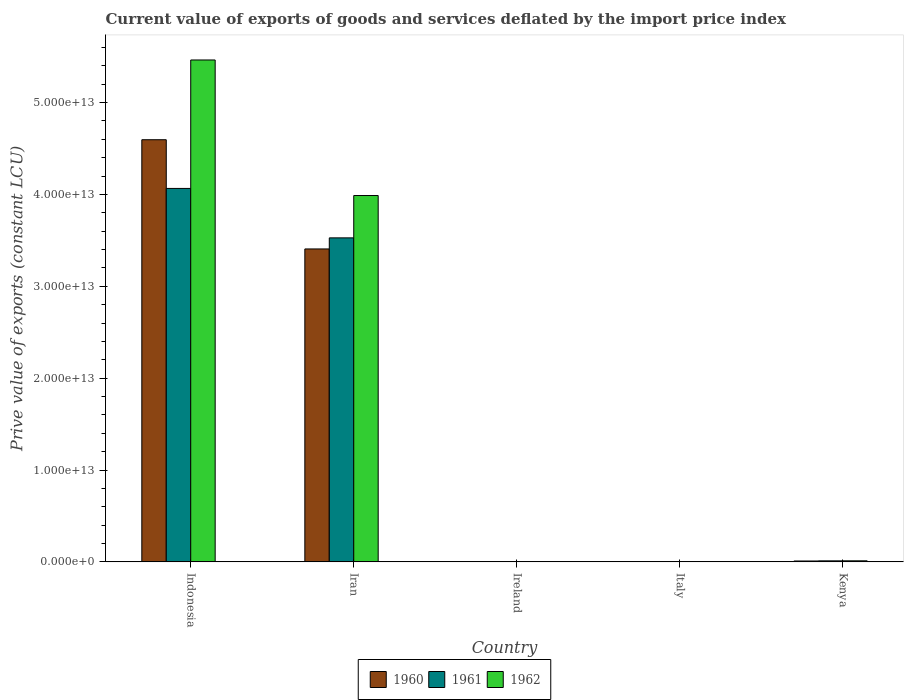How many different coloured bars are there?
Make the answer very short. 3. How many groups of bars are there?
Ensure brevity in your answer.  5. Are the number of bars per tick equal to the number of legend labels?
Make the answer very short. Yes. Are the number of bars on each tick of the X-axis equal?
Make the answer very short. Yes. How many bars are there on the 3rd tick from the left?
Offer a very short reply. 3. How many bars are there on the 4th tick from the right?
Your answer should be very brief. 3. What is the label of the 5th group of bars from the left?
Provide a succinct answer. Kenya. In how many cases, is the number of bars for a given country not equal to the number of legend labels?
Offer a terse response. 0. What is the prive value of exports in 1962 in Ireland?
Offer a terse response. 3.23e+09. Across all countries, what is the maximum prive value of exports in 1960?
Make the answer very short. 4.60e+13. Across all countries, what is the minimum prive value of exports in 1961?
Your response must be concise. 3.22e+09. In which country was the prive value of exports in 1961 minimum?
Your response must be concise. Ireland. What is the total prive value of exports in 1962 in the graph?
Offer a terse response. 9.47e+13. What is the difference between the prive value of exports in 1960 in Indonesia and that in Ireland?
Offer a terse response. 4.59e+13. What is the difference between the prive value of exports in 1960 in Kenya and the prive value of exports in 1961 in Iran?
Give a very brief answer. -3.52e+13. What is the average prive value of exports in 1961 per country?
Make the answer very short. 1.52e+13. What is the difference between the prive value of exports of/in 1961 and prive value of exports of/in 1962 in Kenya?
Make the answer very short. -3.47e+09. In how many countries, is the prive value of exports in 1960 greater than 48000000000000 LCU?
Your answer should be compact. 0. What is the ratio of the prive value of exports in 1960 in Italy to that in Kenya?
Make the answer very short. 0.3. Is the prive value of exports in 1961 in Indonesia less than that in Iran?
Give a very brief answer. No. Is the difference between the prive value of exports in 1961 in Ireland and Italy greater than the difference between the prive value of exports in 1962 in Ireland and Italy?
Your answer should be very brief. Yes. What is the difference between the highest and the second highest prive value of exports in 1962?
Make the answer very short. 3.98e+13. What is the difference between the highest and the lowest prive value of exports in 1961?
Your answer should be compact. 4.06e+13. In how many countries, is the prive value of exports in 1961 greater than the average prive value of exports in 1961 taken over all countries?
Your response must be concise. 2. Is the sum of the prive value of exports in 1960 in Iran and Italy greater than the maximum prive value of exports in 1962 across all countries?
Your answer should be very brief. No. How many bars are there?
Offer a terse response. 15. Are all the bars in the graph horizontal?
Keep it short and to the point. No. What is the difference between two consecutive major ticks on the Y-axis?
Offer a terse response. 1.00e+13. Are the values on the major ticks of Y-axis written in scientific E-notation?
Your answer should be compact. Yes. Where does the legend appear in the graph?
Provide a short and direct response. Bottom center. What is the title of the graph?
Ensure brevity in your answer.  Current value of exports of goods and services deflated by the import price index. Does "2001" appear as one of the legend labels in the graph?
Give a very brief answer. No. What is the label or title of the X-axis?
Make the answer very short. Country. What is the label or title of the Y-axis?
Make the answer very short. Prive value of exports (constant LCU). What is the Prive value of exports (constant LCU) of 1960 in Indonesia?
Make the answer very short. 4.60e+13. What is the Prive value of exports (constant LCU) of 1961 in Indonesia?
Your answer should be very brief. 4.07e+13. What is the Prive value of exports (constant LCU) in 1962 in Indonesia?
Provide a short and direct response. 5.46e+13. What is the Prive value of exports (constant LCU) in 1960 in Iran?
Provide a short and direct response. 3.41e+13. What is the Prive value of exports (constant LCU) of 1961 in Iran?
Your answer should be very brief. 3.53e+13. What is the Prive value of exports (constant LCU) in 1962 in Iran?
Make the answer very short. 3.99e+13. What is the Prive value of exports (constant LCU) in 1960 in Ireland?
Ensure brevity in your answer.  2.78e+09. What is the Prive value of exports (constant LCU) of 1961 in Ireland?
Give a very brief answer. 3.22e+09. What is the Prive value of exports (constant LCU) in 1962 in Ireland?
Provide a short and direct response. 3.23e+09. What is the Prive value of exports (constant LCU) in 1960 in Italy?
Your answer should be compact. 2.88e+1. What is the Prive value of exports (constant LCU) of 1961 in Italy?
Provide a short and direct response. 3.35e+1. What is the Prive value of exports (constant LCU) of 1962 in Italy?
Provide a succinct answer. 3.72e+1. What is the Prive value of exports (constant LCU) in 1960 in Kenya?
Your response must be concise. 9.59e+1. What is the Prive value of exports (constant LCU) of 1961 in Kenya?
Provide a short and direct response. 1.11e+11. What is the Prive value of exports (constant LCU) of 1962 in Kenya?
Keep it short and to the point. 1.15e+11. Across all countries, what is the maximum Prive value of exports (constant LCU) of 1960?
Provide a short and direct response. 4.60e+13. Across all countries, what is the maximum Prive value of exports (constant LCU) of 1961?
Ensure brevity in your answer.  4.07e+13. Across all countries, what is the maximum Prive value of exports (constant LCU) in 1962?
Keep it short and to the point. 5.46e+13. Across all countries, what is the minimum Prive value of exports (constant LCU) of 1960?
Your answer should be very brief. 2.78e+09. Across all countries, what is the minimum Prive value of exports (constant LCU) in 1961?
Provide a succinct answer. 3.22e+09. Across all countries, what is the minimum Prive value of exports (constant LCU) of 1962?
Your answer should be compact. 3.23e+09. What is the total Prive value of exports (constant LCU) of 1960 in the graph?
Ensure brevity in your answer.  8.01e+13. What is the total Prive value of exports (constant LCU) of 1961 in the graph?
Provide a short and direct response. 7.61e+13. What is the total Prive value of exports (constant LCU) in 1962 in the graph?
Provide a short and direct response. 9.47e+13. What is the difference between the Prive value of exports (constant LCU) in 1960 in Indonesia and that in Iran?
Ensure brevity in your answer.  1.19e+13. What is the difference between the Prive value of exports (constant LCU) in 1961 in Indonesia and that in Iran?
Your answer should be very brief. 5.38e+12. What is the difference between the Prive value of exports (constant LCU) of 1962 in Indonesia and that in Iran?
Make the answer very short. 1.48e+13. What is the difference between the Prive value of exports (constant LCU) of 1960 in Indonesia and that in Ireland?
Your response must be concise. 4.59e+13. What is the difference between the Prive value of exports (constant LCU) in 1961 in Indonesia and that in Ireland?
Offer a terse response. 4.06e+13. What is the difference between the Prive value of exports (constant LCU) in 1962 in Indonesia and that in Ireland?
Your answer should be very brief. 5.46e+13. What is the difference between the Prive value of exports (constant LCU) of 1960 in Indonesia and that in Italy?
Offer a very short reply. 4.59e+13. What is the difference between the Prive value of exports (constant LCU) in 1961 in Indonesia and that in Italy?
Provide a short and direct response. 4.06e+13. What is the difference between the Prive value of exports (constant LCU) in 1962 in Indonesia and that in Italy?
Provide a short and direct response. 5.46e+13. What is the difference between the Prive value of exports (constant LCU) of 1960 in Indonesia and that in Kenya?
Offer a very short reply. 4.59e+13. What is the difference between the Prive value of exports (constant LCU) of 1961 in Indonesia and that in Kenya?
Ensure brevity in your answer.  4.05e+13. What is the difference between the Prive value of exports (constant LCU) of 1962 in Indonesia and that in Kenya?
Make the answer very short. 5.45e+13. What is the difference between the Prive value of exports (constant LCU) in 1960 in Iran and that in Ireland?
Give a very brief answer. 3.41e+13. What is the difference between the Prive value of exports (constant LCU) of 1961 in Iran and that in Ireland?
Provide a short and direct response. 3.53e+13. What is the difference between the Prive value of exports (constant LCU) of 1962 in Iran and that in Ireland?
Ensure brevity in your answer.  3.99e+13. What is the difference between the Prive value of exports (constant LCU) in 1960 in Iran and that in Italy?
Make the answer very short. 3.40e+13. What is the difference between the Prive value of exports (constant LCU) of 1961 in Iran and that in Italy?
Provide a succinct answer. 3.52e+13. What is the difference between the Prive value of exports (constant LCU) of 1962 in Iran and that in Italy?
Provide a short and direct response. 3.98e+13. What is the difference between the Prive value of exports (constant LCU) in 1960 in Iran and that in Kenya?
Ensure brevity in your answer.  3.40e+13. What is the difference between the Prive value of exports (constant LCU) in 1961 in Iran and that in Kenya?
Your answer should be compact. 3.52e+13. What is the difference between the Prive value of exports (constant LCU) of 1962 in Iran and that in Kenya?
Provide a short and direct response. 3.98e+13. What is the difference between the Prive value of exports (constant LCU) of 1960 in Ireland and that in Italy?
Keep it short and to the point. -2.60e+1. What is the difference between the Prive value of exports (constant LCU) of 1961 in Ireland and that in Italy?
Your answer should be compact. -3.03e+1. What is the difference between the Prive value of exports (constant LCU) in 1962 in Ireland and that in Italy?
Give a very brief answer. -3.40e+1. What is the difference between the Prive value of exports (constant LCU) of 1960 in Ireland and that in Kenya?
Your answer should be compact. -9.31e+1. What is the difference between the Prive value of exports (constant LCU) of 1961 in Ireland and that in Kenya?
Provide a succinct answer. -1.08e+11. What is the difference between the Prive value of exports (constant LCU) of 1962 in Ireland and that in Kenya?
Make the answer very short. -1.11e+11. What is the difference between the Prive value of exports (constant LCU) in 1960 in Italy and that in Kenya?
Your answer should be compact. -6.71e+1. What is the difference between the Prive value of exports (constant LCU) of 1961 in Italy and that in Kenya?
Offer a terse response. -7.77e+1. What is the difference between the Prive value of exports (constant LCU) of 1962 in Italy and that in Kenya?
Your answer should be very brief. -7.75e+1. What is the difference between the Prive value of exports (constant LCU) of 1960 in Indonesia and the Prive value of exports (constant LCU) of 1961 in Iran?
Your answer should be very brief. 1.07e+13. What is the difference between the Prive value of exports (constant LCU) of 1960 in Indonesia and the Prive value of exports (constant LCU) of 1962 in Iran?
Your response must be concise. 6.07e+12. What is the difference between the Prive value of exports (constant LCU) of 1961 in Indonesia and the Prive value of exports (constant LCU) of 1962 in Iran?
Provide a short and direct response. 7.73e+11. What is the difference between the Prive value of exports (constant LCU) in 1960 in Indonesia and the Prive value of exports (constant LCU) in 1961 in Ireland?
Make the answer very short. 4.59e+13. What is the difference between the Prive value of exports (constant LCU) of 1960 in Indonesia and the Prive value of exports (constant LCU) of 1962 in Ireland?
Offer a very short reply. 4.59e+13. What is the difference between the Prive value of exports (constant LCU) of 1961 in Indonesia and the Prive value of exports (constant LCU) of 1962 in Ireland?
Offer a terse response. 4.06e+13. What is the difference between the Prive value of exports (constant LCU) of 1960 in Indonesia and the Prive value of exports (constant LCU) of 1961 in Italy?
Your answer should be very brief. 4.59e+13. What is the difference between the Prive value of exports (constant LCU) in 1960 in Indonesia and the Prive value of exports (constant LCU) in 1962 in Italy?
Your response must be concise. 4.59e+13. What is the difference between the Prive value of exports (constant LCU) of 1961 in Indonesia and the Prive value of exports (constant LCU) of 1962 in Italy?
Make the answer very short. 4.06e+13. What is the difference between the Prive value of exports (constant LCU) in 1960 in Indonesia and the Prive value of exports (constant LCU) in 1961 in Kenya?
Keep it short and to the point. 4.58e+13. What is the difference between the Prive value of exports (constant LCU) of 1960 in Indonesia and the Prive value of exports (constant LCU) of 1962 in Kenya?
Make the answer very short. 4.58e+13. What is the difference between the Prive value of exports (constant LCU) of 1961 in Indonesia and the Prive value of exports (constant LCU) of 1962 in Kenya?
Give a very brief answer. 4.05e+13. What is the difference between the Prive value of exports (constant LCU) in 1960 in Iran and the Prive value of exports (constant LCU) in 1961 in Ireland?
Give a very brief answer. 3.41e+13. What is the difference between the Prive value of exports (constant LCU) of 1960 in Iran and the Prive value of exports (constant LCU) of 1962 in Ireland?
Keep it short and to the point. 3.41e+13. What is the difference between the Prive value of exports (constant LCU) in 1961 in Iran and the Prive value of exports (constant LCU) in 1962 in Ireland?
Give a very brief answer. 3.53e+13. What is the difference between the Prive value of exports (constant LCU) in 1960 in Iran and the Prive value of exports (constant LCU) in 1961 in Italy?
Offer a terse response. 3.40e+13. What is the difference between the Prive value of exports (constant LCU) in 1960 in Iran and the Prive value of exports (constant LCU) in 1962 in Italy?
Your answer should be very brief. 3.40e+13. What is the difference between the Prive value of exports (constant LCU) of 1961 in Iran and the Prive value of exports (constant LCU) of 1962 in Italy?
Provide a succinct answer. 3.52e+13. What is the difference between the Prive value of exports (constant LCU) of 1960 in Iran and the Prive value of exports (constant LCU) of 1961 in Kenya?
Provide a short and direct response. 3.40e+13. What is the difference between the Prive value of exports (constant LCU) of 1960 in Iran and the Prive value of exports (constant LCU) of 1962 in Kenya?
Keep it short and to the point. 3.39e+13. What is the difference between the Prive value of exports (constant LCU) in 1961 in Iran and the Prive value of exports (constant LCU) in 1962 in Kenya?
Your answer should be very brief. 3.52e+13. What is the difference between the Prive value of exports (constant LCU) of 1960 in Ireland and the Prive value of exports (constant LCU) of 1961 in Italy?
Keep it short and to the point. -3.08e+1. What is the difference between the Prive value of exports (constant LCU) of 1960 in Ireland and the Prive value of exports (constant LCU) of 1962 in Italy?
Provide a succinct answer. -3.44e+1. What is the difference between the Prive value of exports (constant LCU) of 1961 in Ireland and the Prive value of exports (constant LCU) of 1962 in Italy?
Give a very brief answer. -3.40e+1. What is the difference between the Prive value of exports (constant LCU) in 1960 in Ireland and the Prive value of exports (constant LCU) in 1961 in Kenya?
Offer a terse response. -1.08e+11. What is the difference between the Prive value of exports (constant LCU) of 1960 in Ireland and the Prive value of exports (constant LCU) of 1962 in Kenya?
Make the answer very short. -1.12e+11. What is the difference between the Prive value of exports (constant LCU) in 1961 in Ireland and the Prive value of exports (constant LCU) in 1962 in Kenya?
Your answer should be compact. -1.11e+11. What is the difference between the Prive value of exports (constant LCU) in 1960 in Italy and the Prive value of exports (constant LCU) in 1961 in Kenya?
Make the answer very short. -8.24e+1. What is the difference between the Prive value of exports (constant LCU) in 1960 in Italy and the Prive value of exports (constant LCU) in 1962 in Kenya?
Offer a terse response. -8.59e+1. What is the difference between the Prive value of exports (constant LCU) of 1961 in Italy and the Prive value of exports (constant LCU) of 1962 in Kenya?
Make the answer very short. -8.12e+1. What is the average Prive value of exports (constant LCU) in 1960 per country?
Ensure brevity in your answer.  1.60e+13. What is the average Prive value of exports (constant LCU) of 1961 per country?
Offer a terse response. 1.52e+13. What is the average Prive value of exports (constant LCU) of 1962 per country?
Your answer should be very brief. 1.89e+13. What is the difference between the Prive value of exports (constant LCU) of 1960 and Prive value of exports (constant LCU) of 1961 in Indonesia?
Ensure brevity in your answer.  5.30e+12. What is the difference between the Prive value of exports (constant LCU) of 1960 and Prive value of exports (constant LCU) of 1962 in Indonesia?
Make the answer very short. -8.68e+12. What is the difference between the Prive value of exports (constant LCU) of 1961 and Prive value of exports (constant LCU) of 1962 in Indonesia?
Make the answer very short. -1.40e+13. What is the difference between the Prive value of exports (constant LCU) in 1960 and Prive value of exports (constant LCU) in 1961 in Iran?
Your answer should be very brief. -1.21e+12. What is the difference between the Prive value of exports (constant LCU) in 1960 and Prive value of exports (constant LCU) in 1962 in Iran?
Give a very brief answer. -5.81e+12. What is the difference between the Prive value of exports (constant LCU) of 1961 and Prive value of exports (constant LCU) of 1962 in Iran?
Provide a short and direct response. -4.61e+12. What is the difference between the Prive value of exports (constant LCU) in 1960 and Prive value of exports (constant LCU) in 1961 in Ireland?
Offer a very short reply. -4.39e+08. What is the difference between the Prive value of exports (constant LCU) of 1960 and Prive value of exports (constant LCU) of 1962 in Ireland?
Provide a succinct answer. -4.49e+08. What is the difference between the Prive value of exports (constant LCU) in 1961 and Prive value of exports (constant LCU) in 1962 in Ireland?
Offer a very short reply. -9.94e+06. What is the difference between the Prive value of exports (constant LCU) of 1960 and Prive value of exports (constant LCU) of 1961 in Italy?
Ensure brevity in your answer.  -4.73e+09. What is the difference between the Prive value of exports (constant LCU) in 1960 and Prive value of exports (constant LCU) in 1962 in Italy?
Offer a terse response. -8.38e+09. What is the difference between the Prive value of exports (constant LCU) in 1961 and Prive value of exports (constant LCU) in 1962 in Italy?
Ensure brevity in your answer.  -3.65e+09. What is the difference between the Prive value of exports (constant LCU) of 1960 and Prive value of exports (constant LCU) of 1961 in Kenya?
Your answer should be very brief. -1.54e+1. What is the difference between the Prive value of exports (constant LCU) in 1960 and Prive value of exports (constant LCU) in 1962 in Kenya?
Your answer should be compact. -1.88e+1. What is the difference between the Prive value of exports (constant LCU) in 1961 and Prive value of exports (constant LCU) in 1962 in Kenya?
Ensure brevity in your answer.  -3.47e+09. What is the ratio of the Prive value of exports (constant LCU) in 1960 in Indonesia to that in Iran?
Offer a terse response. 1.35. What is the ratio of the Prive value of exports (constant LCU) of 1961 in Indonesia to that in Iran?
Offer a very short reply. 1.15. What is the ratio of the Prive value of exports (constant LCU) in 1962 in Indonesia to that in Iran?
Offer a terse response. 1.37. What is the ratio of the Prive value of exports (constant LCU) of 1960 in Indonesia to that in Ireland?
Ensure brevity in your answer.  1.65e+04. What is the ratio of the Prive value of exports (constant LCU) in 1961 in Indonesia to that in Ireland?
Provide a succinct answer. 1.26e+04. What is the ratio of the Prive value of exports (constant LCU) of 1962 in Indonesia to that in Ireland?
Ensure brevity in your answer.  1.69e+04. What is the ratio of the Prive value of exports (constant LCU) in 1960 in Indonesia to that in Italy?
Your answer should be compact. 1594.87. What is the ratio of the Prive value of exports (constant LCU) in 1961 in Indonesia to that in Italy?
Provide a short and direct response. 1211.97. What is the ratio of the Prive value of exports (constant LCU) of 1962 in Indonesia to that in Italy?
Your answer should be compact. 1468.91. What is the ratio of the Prive value of exports (constant LCU) in 1960 in Indonesia to that in Kenya?
Your answer should be compact. 479.27. What is the ratio of the Prive value of exports (constant LCU) of 1961 in Indonesia to that in Kenya?
Give a very brief answer. 365.46. What is the ratio of the Prive value of exports (constant LCU) of 1962 in Indonesia to that in Kenya?
Your answer should be very brief. 476.32. What is the ratio of the Prive value of exports (constant LCU) of 1960 in Iran to that in Ireland?
Offer a very short reply. 1.23e+04. What is the ratio of the Prive value of exports (constant LCU) of 1961 in Iran to that in Ireland?
Your answer should be compact. 1.10e+04. What is the ratio of the Prive value of exports (constant LCU) of 1962 in Iran to that in Ireland?
Give a very brief answer. 1.24e+04. What is the ratio of the Prive value of exports (constant LCU) in 1960 in Iran to that in Italy?
Provide a short and direct response. 1182.28. What is the ratio of the Prive value of exports (constant LCU) of 1961 in Iran to that in Italy?
Provide a short and direct response. 1051.5. What is the ratio of the Prive value of exports (constant LCU) of 1962 in Iran to that in Italy?
Offer a terse response. 1072.18. What is the ratio of the Prive value of exports (constant LCU) in 1960 in Iran to that in Kenya?
Ensure brevity in your answer.  355.28. What is the ratio of the Prive value of exports (constant LCU) of 1961 in Iran to that in Kenya?
Provide a succinct answer. 317.07. What is the ratio of the Prive value of exports (constant LCU) of 1962 in Iran to that in Kenya?
Ensure brevity in your answer.  347.67. What is the ratio of the Prive value of exports (constant LCU) of 1960 in Ireland to that in Italy?
Provide a short and direct response. 0.1. What is the ratio of the Prive value of exports (constant LCU) in 1961 in Ireland to that in Italy?
Your response must be concise. 0.1. What is the ratio of the Prive value of exports (constant LCU) in 1962 in Ireland to that in Italy?
Offer a very short reply. 0.09. What is the ratio of the Prive value of exports (constant LCU) of 1960 in Ireland to that in Kenya?
Provide a short and direct response. 0.03. What is the ratio of the Prive value of exports (constant LCU) of 1961 in Ireland to that in Kenya?
Offer a terse response. 0.03. What is the ratio of the Prive value of exports (constant LCU) in 1962 in Ireland to that in Kenya?
Offer a terse response. 0.03. What is the ratio of the Prive value of exports (constant LCU) in 1960 in Italy to that in Kenya?
Your response must be concise. 0.3. What is the ratio of the Prive value of exports (constant LCU) in 1961 in Italy to that in Kenya?
Give a very brief answer. 0.3. What is the ratio of the Prive value of exports (constant LCU) of 1962 in Italy to that in Kenya?
Ensure brevity in your answer.  0.32. What is the difference between the highest and the second highest Prive value of exports (constant LCU) in 1960?
Provide a succinct answer. 1.19e+13. What is the difference between the highest and the second highest Prive value of exports (constant LCU) in 1961?
Keep it short and to the point. 5.38e+12. What is the difference between the highest and the second highest Prive value of exports (constant LCU) in 1962?
Your response must be concise. 1.48e+13. What is the difference between the highest and the lowest Prive value of exports (constant LCU) of 1960?
Ensure brevity in your answer.  4.59e+13. What is the difference between the highest and the lowest Prive value of exports (constant LCU) of 1961?
Ensure brevity in your answer.  4.06e+13. What is the difference between the highest and the lowest Prive value of exports (constant LCU) of 1962?
Ensure brevity in your answer.  5.46e+13. 